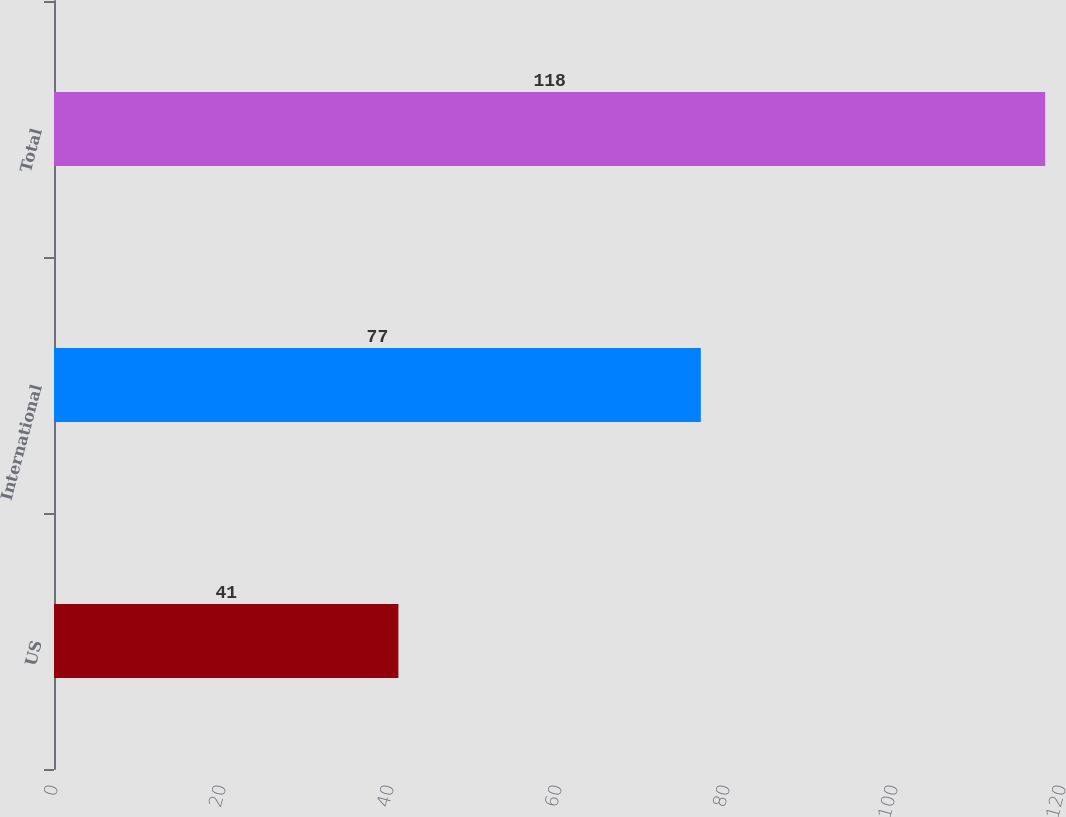<chart> <loc_0><loc_0><loc_500><loc_500><bar_chart><fcel>US<fcel>International<fcel>Total<nl><fcel>41<fcel>77<fcel>118<nl></chart> 